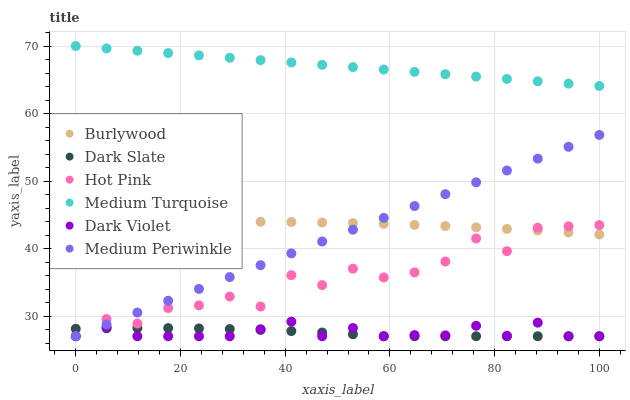Does Dark Slate have the minimum area under the curve?
Answer yes or no. Yes. Does Medium Turquoise have the maximum area under the curve?
Answer yes or no. Yes. Does Hot Pink have the minimum area under the curve?
Answer yes or no. No. Does Hot Pink have the maximum area under the curve?
Answer yes or no. No. Is Medium Periwinkle the smoothest?
Answer yes or no. Yes. Is Hot Pink the roughest?
Answer yes or no. Yes. Is Hot Pink the smoothest?
Answer yes or no. No. Is Medium Periwinkle the roughest?
Answer yes or no. No. Does Hot Pink have the lowest value?
Answer yes or no. Yes. Does Medium Turquoise have the lowest value?
Answer yes or no. No. Does Medium Turquoise have the highest value?
Answer yes or no. Yes. Does Hot Pink have the highest value?
Answer yes or no. No. Is Dark Violet less than Burlywood?
Answer yes or no. Yes. Is Medium Turquoise greater than Burlywood?
Answer yes or no. Yes. Does Medium Periwinkle intersect Dark Slate?
Answer yes or no. Yes. Is Medium Periwinkle less than Dark Slate?
Answer yes or no. No. Is Medium Periwinkle greater than Dark Slate?
Answer yes or no. No. Does Dark Violet intersect Burlywood?
Answer yes or no. No. 